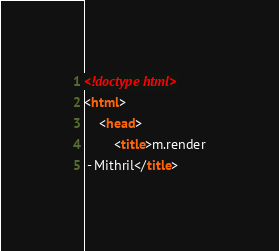<code> <loc_0><loc_0><loc_500><loc_500><_HTML_><!doctype html>
<html>
	<head>
		<title>m.render - Mithril</title></code> 